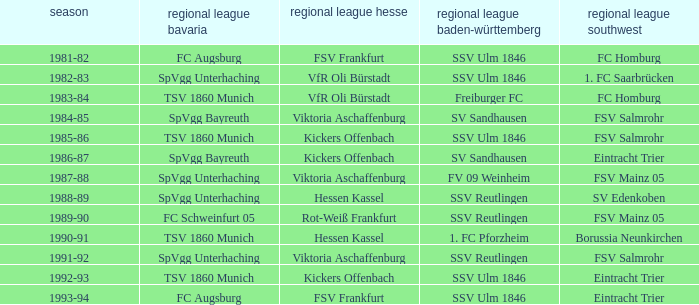Which Season ha spvgg bayreuth and eintracht trier? 1986-87. 